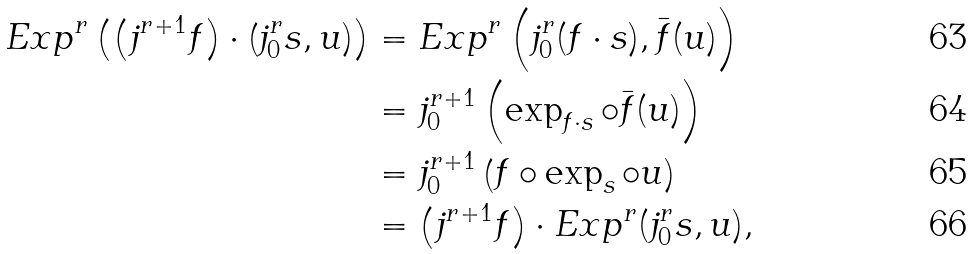Convert formula to latex. <formula><loc_0><loc_0><loc_500><loc_500>E x p ^ { r } \left ( \left ( j ^ { r + 1 } f \right ) \cdot \left ( j _ { 0 } ^ { r } s , u \right ) \right ) & = E x p ^ { r } \left ( j _ { 0 } ^ { r } ( f \cdot s ) , \bar { f } ( u ) \right ) \\ & = j _ { 0 } ^ { r + 1 } \left ( \exp _ { f \cdot s } \circ \bar { f } ( u ) \right ) \\ & = j _ { 0 } ^ { r + 1 } \left ( f \circ \exp _ { s } \circ u \right ) \\ & = \left ( j ^ { r + 1 } f \right ) \cdot E x p ^ { r } ( j _ { 0 } ^ { r } s , u ) ,</formula> 